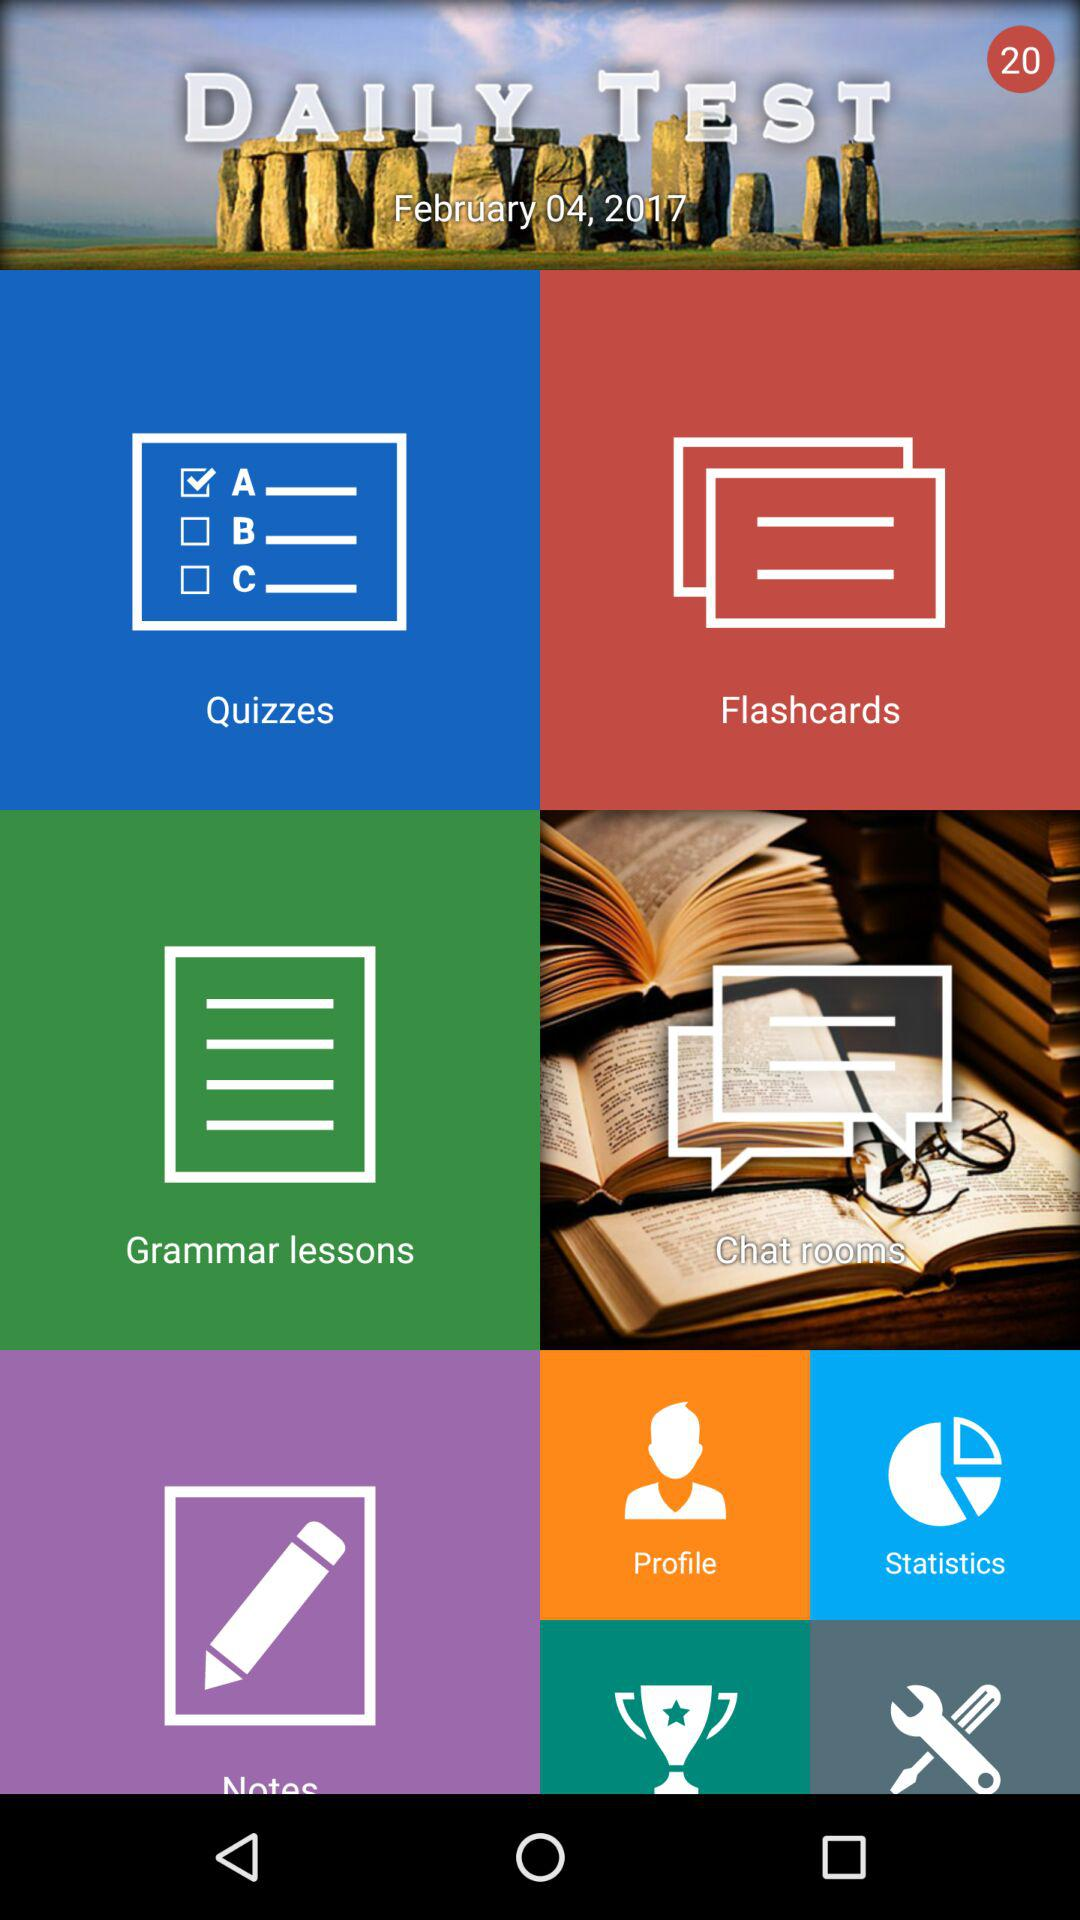What is the date given for the daily test? The date is February 04, 2017. 